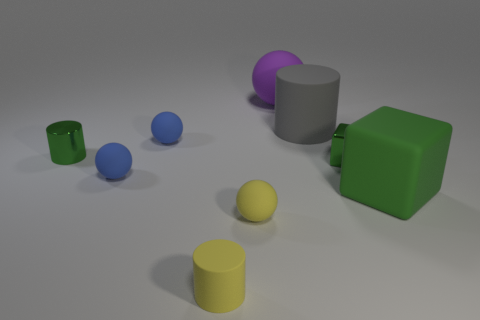What material do the two blue spheres seem to be made of? The two blue spheres appear to have a matte finish, suggesting they are made from a material that diffuses light, such as plastic or a coated metal. 